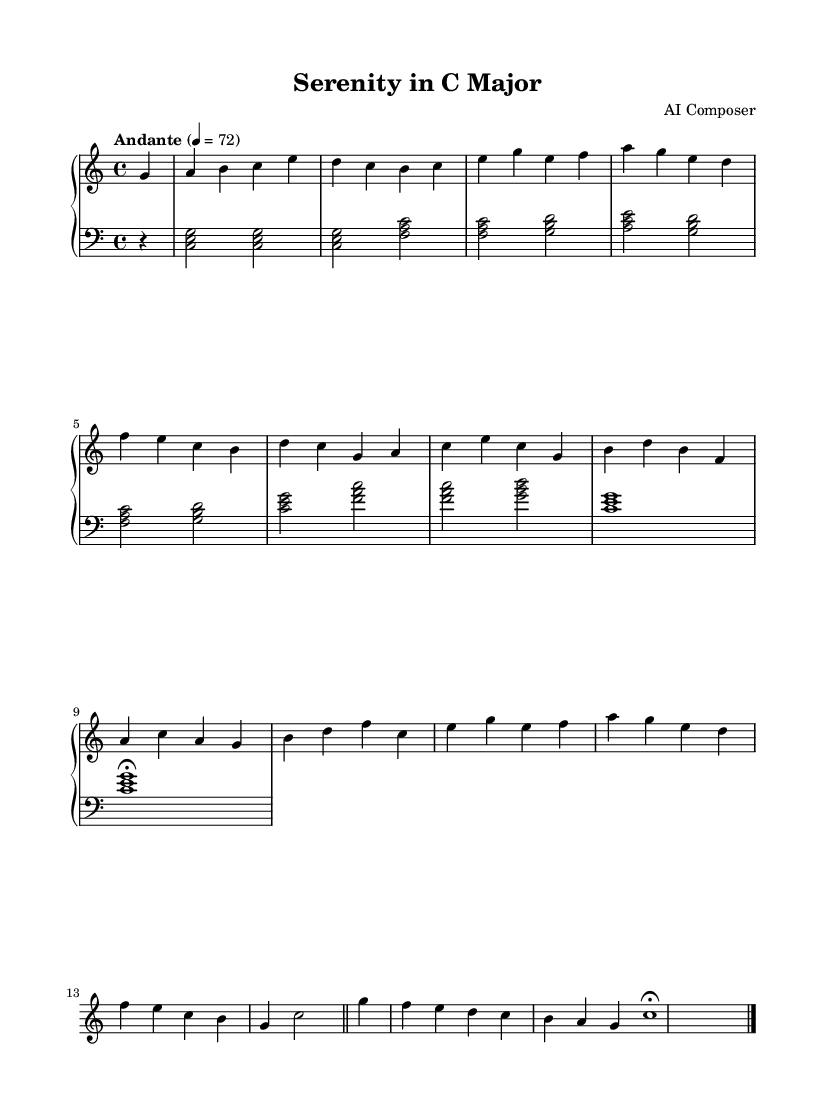What is the key signature of this music? The key signature is C major, which is indicated by the absence of any sharps or flats in the music.
Answer: C major What is the time signature of this piece? The time signature shown at the beginning of the music is 4/4, meaning there are four beats in each measure.
Answer: 4/4 What is the tempo marking of this composition? The tempo is marked as "Andante," which suggests a moderate pace, and the metronome marking is set to quarter note equals 72 beats per minute.
Answer: Andante How many measures are in the piece? Counting the measures sequentially from the start to the end indicates there are eight measures in total, including the final measure.
Answer: 8 What is the first note of the right-hand part? The first note in the right-hand part is G, which is the starting note of the piece and appears on the second line (G-line) of the staff.
Answer: G What is the highest note played in the left hand? In the left-hand part, the highest note is C, which can be found in the first chord and is part of the C major triad.
Answer: C What is the last note of this composition? The final note is C, which is a whole note that concludes the piece and is located in the bass clef on the first line.
Answer: C 